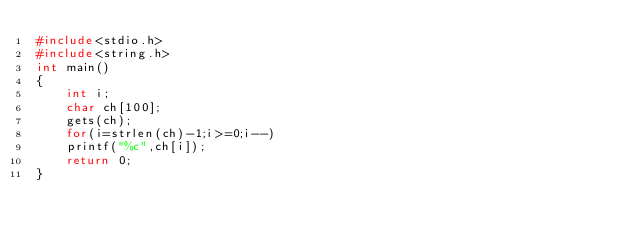<code> <loc_0><loc_0><loc_500><loc_500><_C_>#include<stdio.h>
#include<string.h>
int main()
{
	int i;
	char ch[100];
	gets(ch);
	for(i=strlen(ch)-1;i>=0;i--)
	printf("%c",ch[i]);
	return 0;
}</code> 